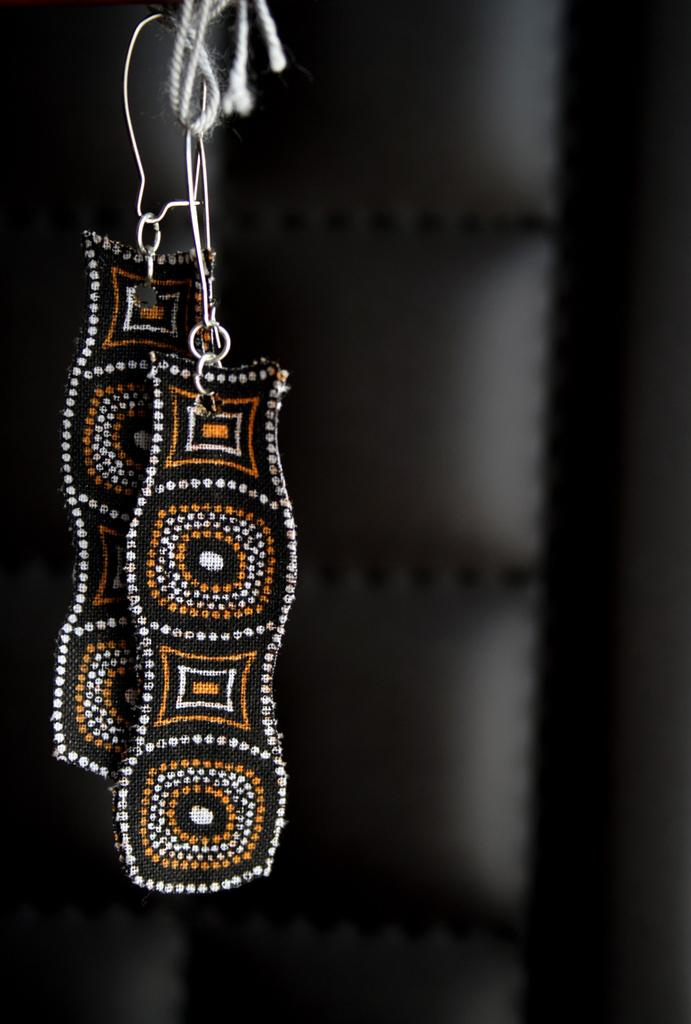What type of accessory is featured in the image? There is a pair of earrings in the image. How are the earrings displayed in the image? The earrings are hanging from a thread. What can be observed about the lighting or color scheme in the image? The background of the image is dark. What type of jam is being served for breakfast in the image? There is no jam or breakfast depicted in the image; it features a pair of earrings hanging from a thread against a dark background. How is the scarf being used in the image? There is no scarf present in the image. 